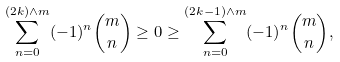Convert formula to latex. <formula><loc_0><loc_0><loc_500><loc_500>\sum ^ { ( 2 k ) \wedge m } _ { n = 0 } ( - 1 ) ^ { n } \binom { m } { n } \geq 0 \geq \sum ^ { ( 2 k - 1 ) \wedge m } _ { n = 0 } ( - 1 ) ^ { n } \binom { m } { n } ,</formula> 